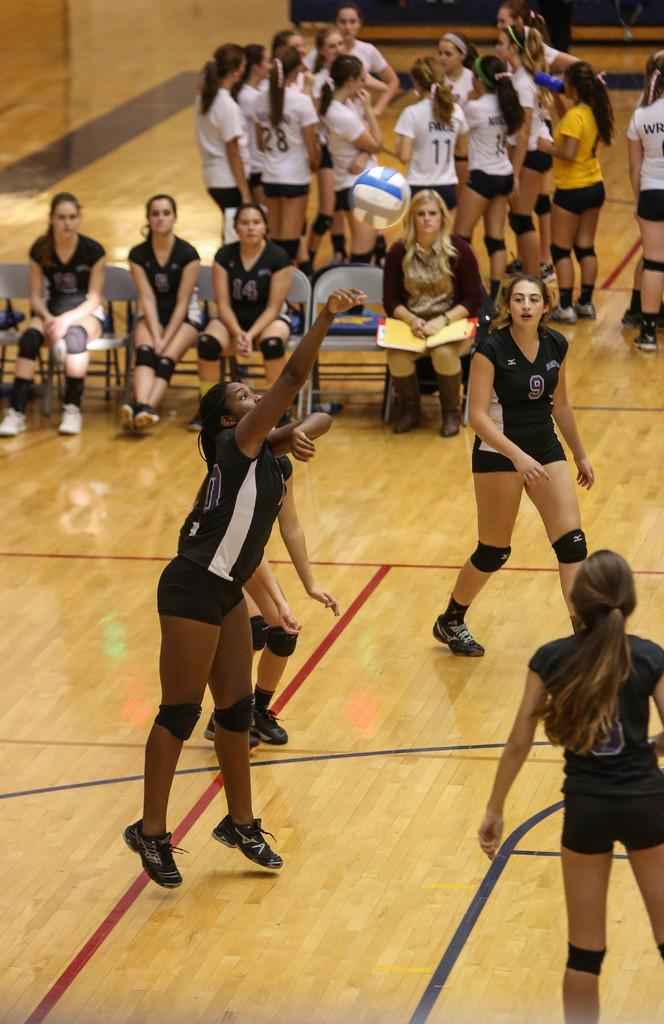What are the girls doing in the image? The girls are playing with a football in the image. Where are the girls playing? The girls are playing on the ground. What are some of the positions the girls are in? Some girls are sitting on chairs, while others are standing in the image. What type of jeans are the girls wearing in the image? There is no mention of jeans in the image, so we cannot determine what type of jeans the girls are wearing. 